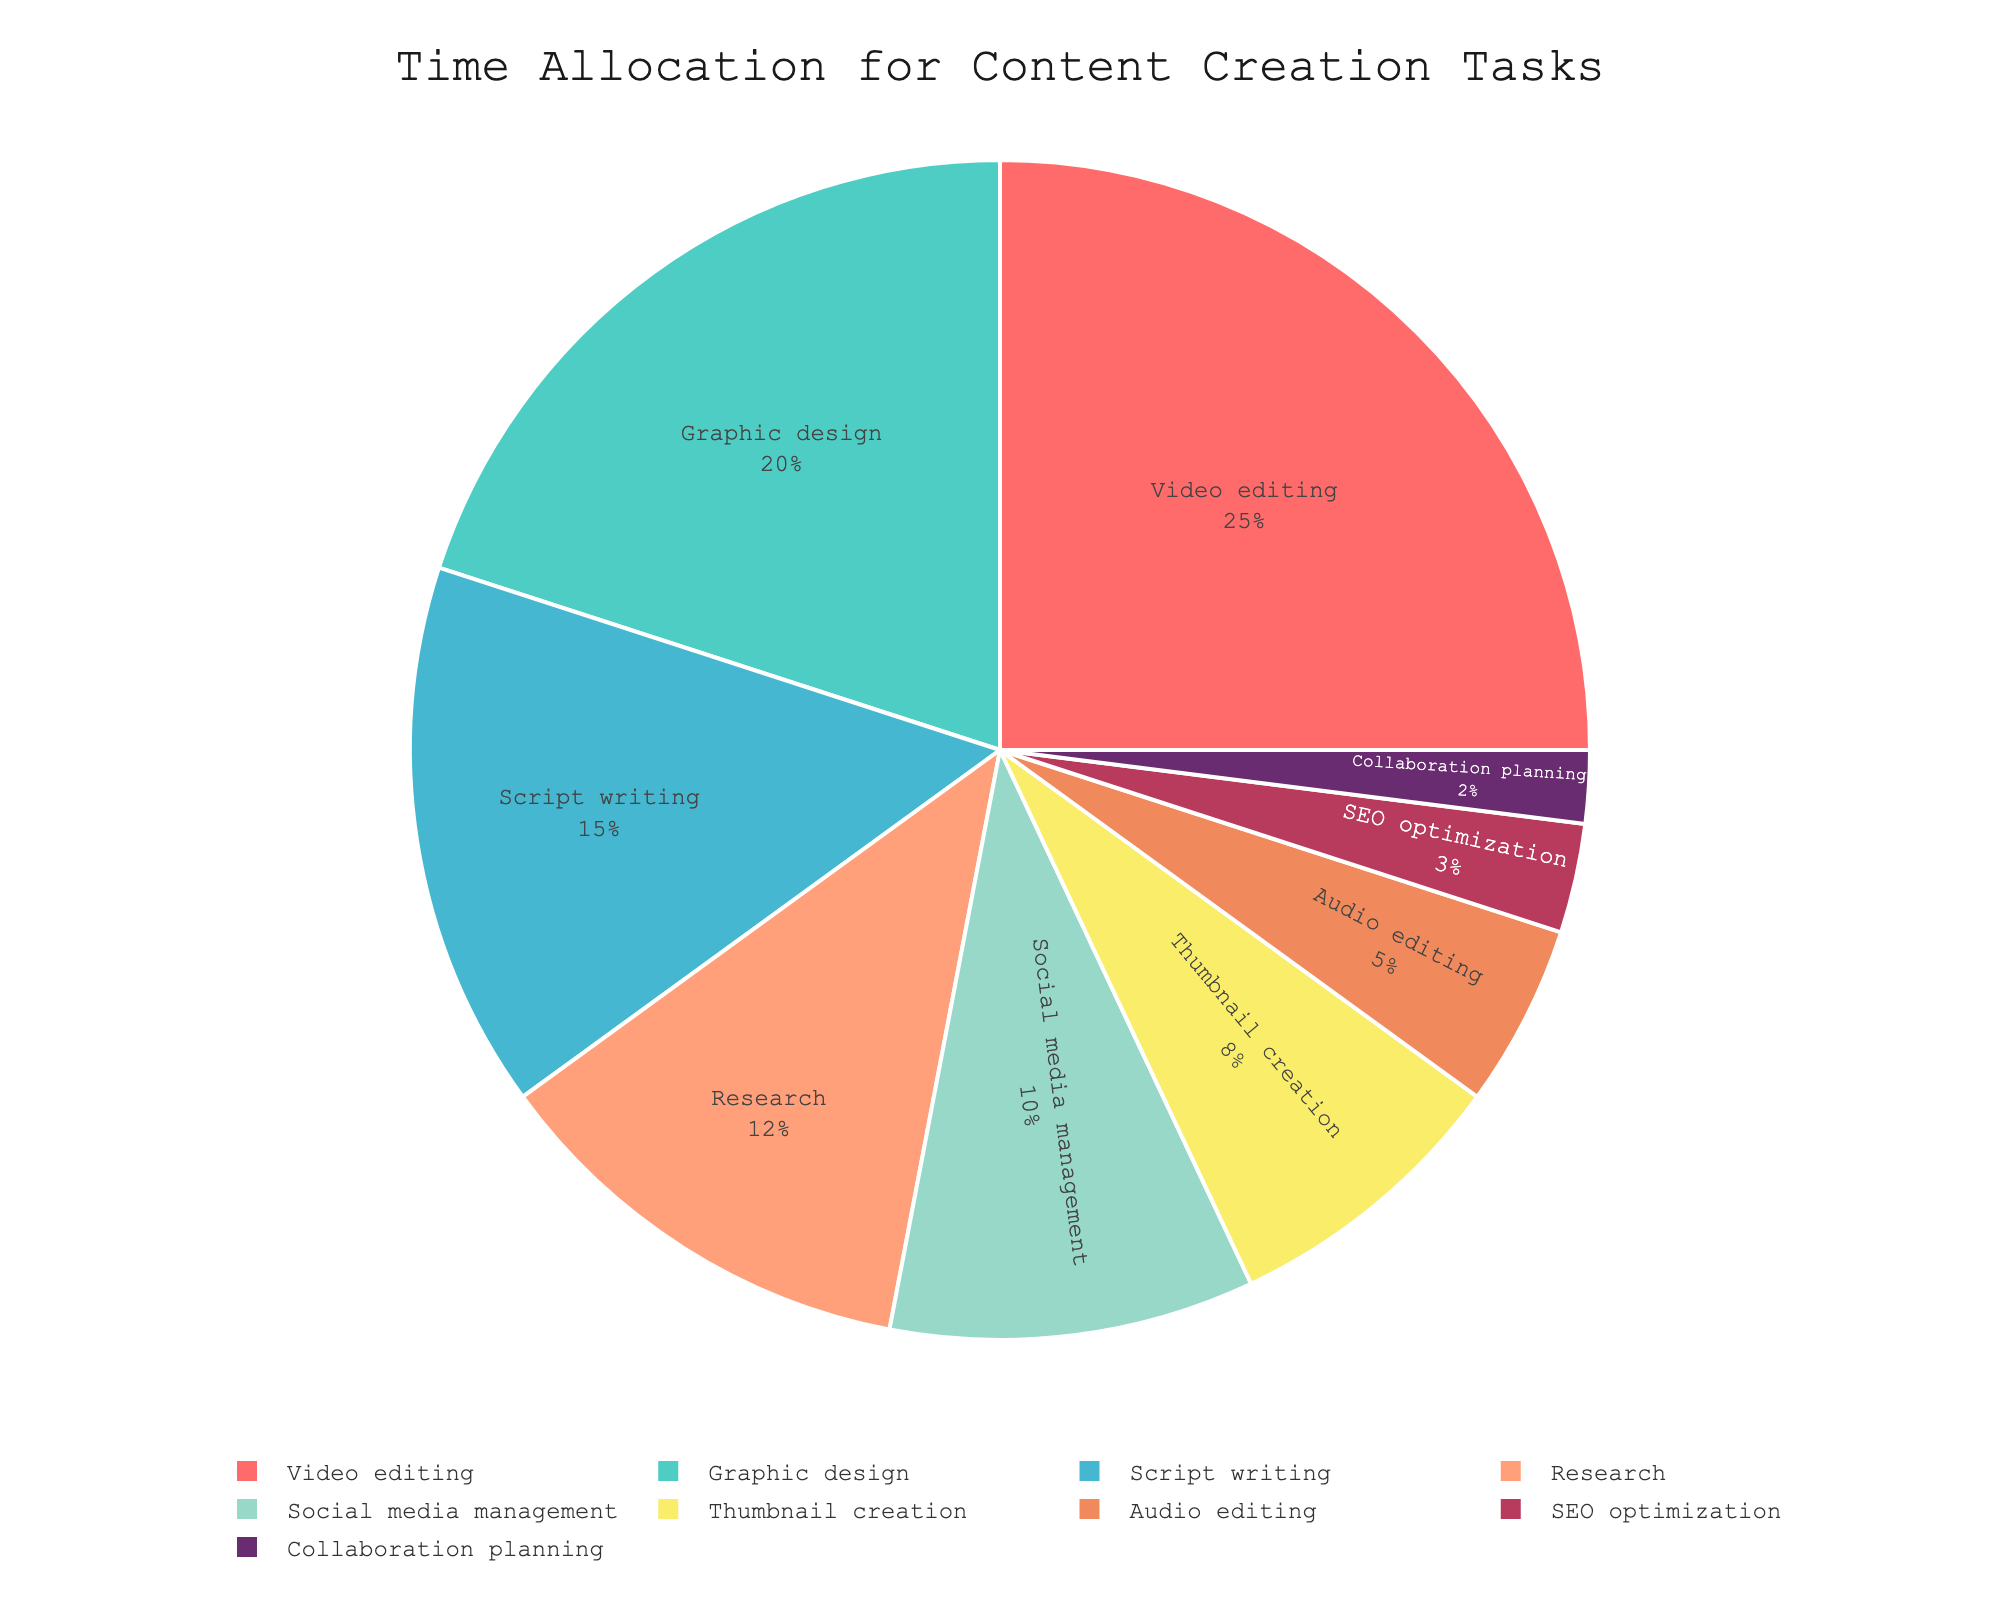What task has the largest allocation of time? The pie chart shows the percentages of time allocated to different content creation tasks. The segment for "Video editing" is the largest.
Answer: Video editing How much more time is allocated to Video editing compared to Script writing? The pie chart shows 25% allocated to Video editing and 15% to Script writing. The difference is 25% - 15% = 10%.
Answer: 10% Which tasks have a combined time allocation of 20%? From the chart, Audio editing has 5%, and Thumbnail creation has 8%, adding Collaboration planning with 2% and SEO optimization with 3%, their sum is 5% + 8% + 2% + 3% = 18%. So, Graphic design (20%) alone matches the requirement.
Answer: Graphic design Is more time allocated to Social media management or Research? By examining the chart, Social media management has 10% while Research has 12%. Therefore, more time is allocated to Research.
Answer: Research What is the second least allocated task and its percentage? The pie chart shows the allocations, sorted from least to highest: Collaboration planning (2%), SEO optimization (3%). SEO optimization is the second least.
Answer: SEO optimization, 3% If Social media management time were doubled, what would it become in the pie chart? The pie chart currently shows Social media management at 10%. Doubling this would result in 10% * 2 = 20%.
Answer: 20% What is the combined percentage of time allocated to tasks related to editing (Video, Audio)? The pie chart shows Video editing at 25% and Audio editing at 5%. Adding these together gives 25% + 5% = 30%.
Answer: 30% Which tasks have allocations less than 10%? By looking at the chart, the tasks with less than 10% are Thumbnail creation (8%), Audio editing (5%), SEO optimization (3%), and Collaboration planning (2%).
Answer: Thumbnail creation, Audio editing, SEO optimization, Collaboration planning What color is the section for Script writing? From the custom palette, Script writing is represented by the color blue (hex: #45B7D1). The exact color is not explicitly listed in the prompt, but provided color details can help deduce this.
Answer: Blue 